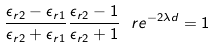Convert formula to latex. <formula><loc_0><loc_0><loc_500><loc_500>\frac { \epsilon _ { r 2 } - \epsilon _ { r 1 } } { \epsilon _ { r 2 } + \epsilon _ { r 1 } } \frac { \epsilon _ { r 2 } - 1 } { \epsilon _ { r 2 } + 1 } \ r e ^ { - 2 \lambda d } = 1</formula> 